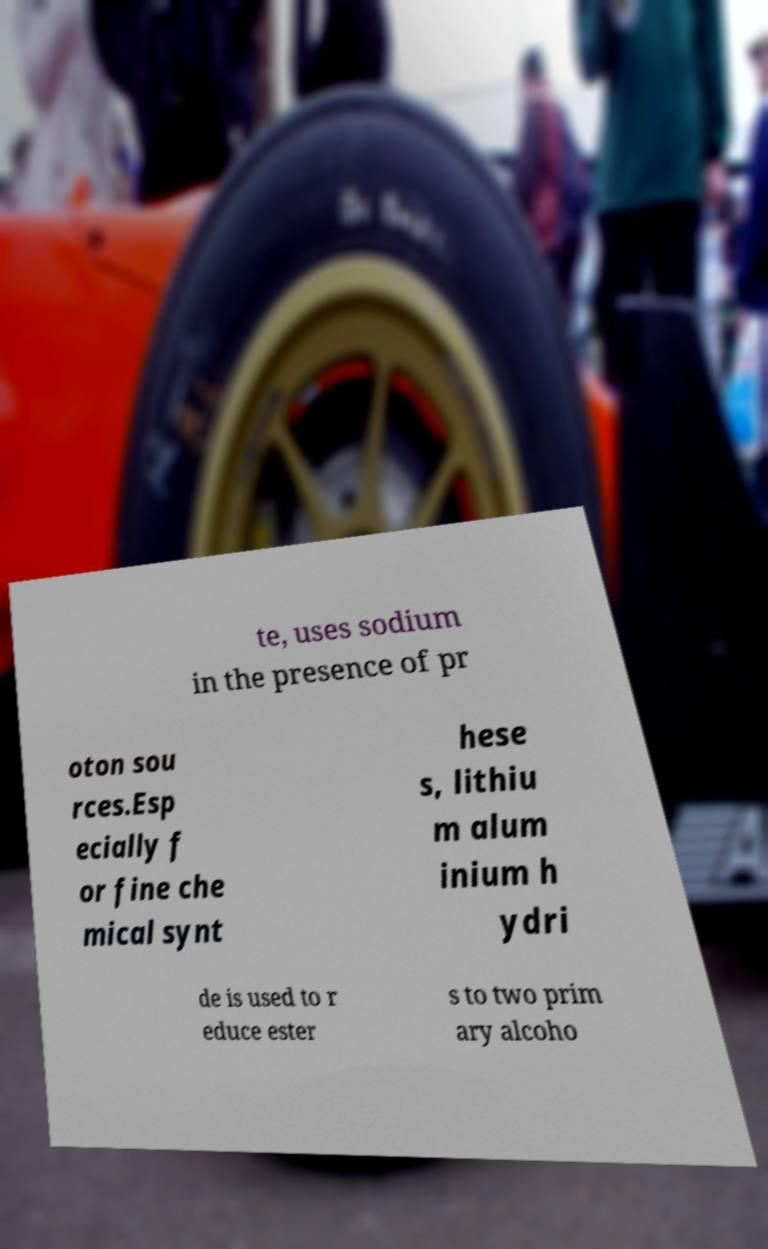There's text embedded in this image that I need extracted. Can you transcribe it verbatim? te, uses sodium in the presence of pr oton sou rces.Esp ecially f or fine che mical synt hese s, lithiu m alum inium h ydri de is used to r educe ester s to two prim ary alcoho 